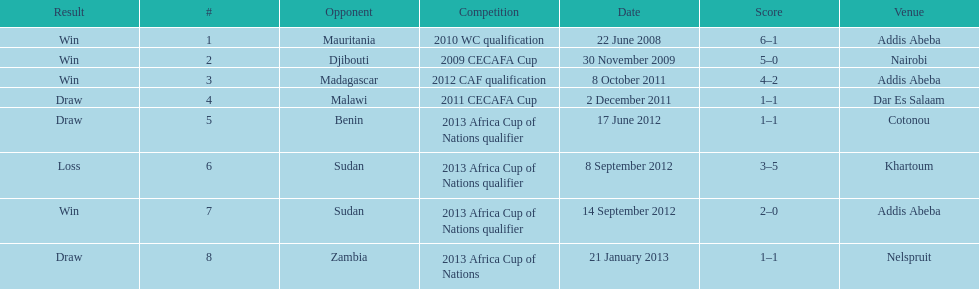What date gives was their only loss? 8 September 2012. 